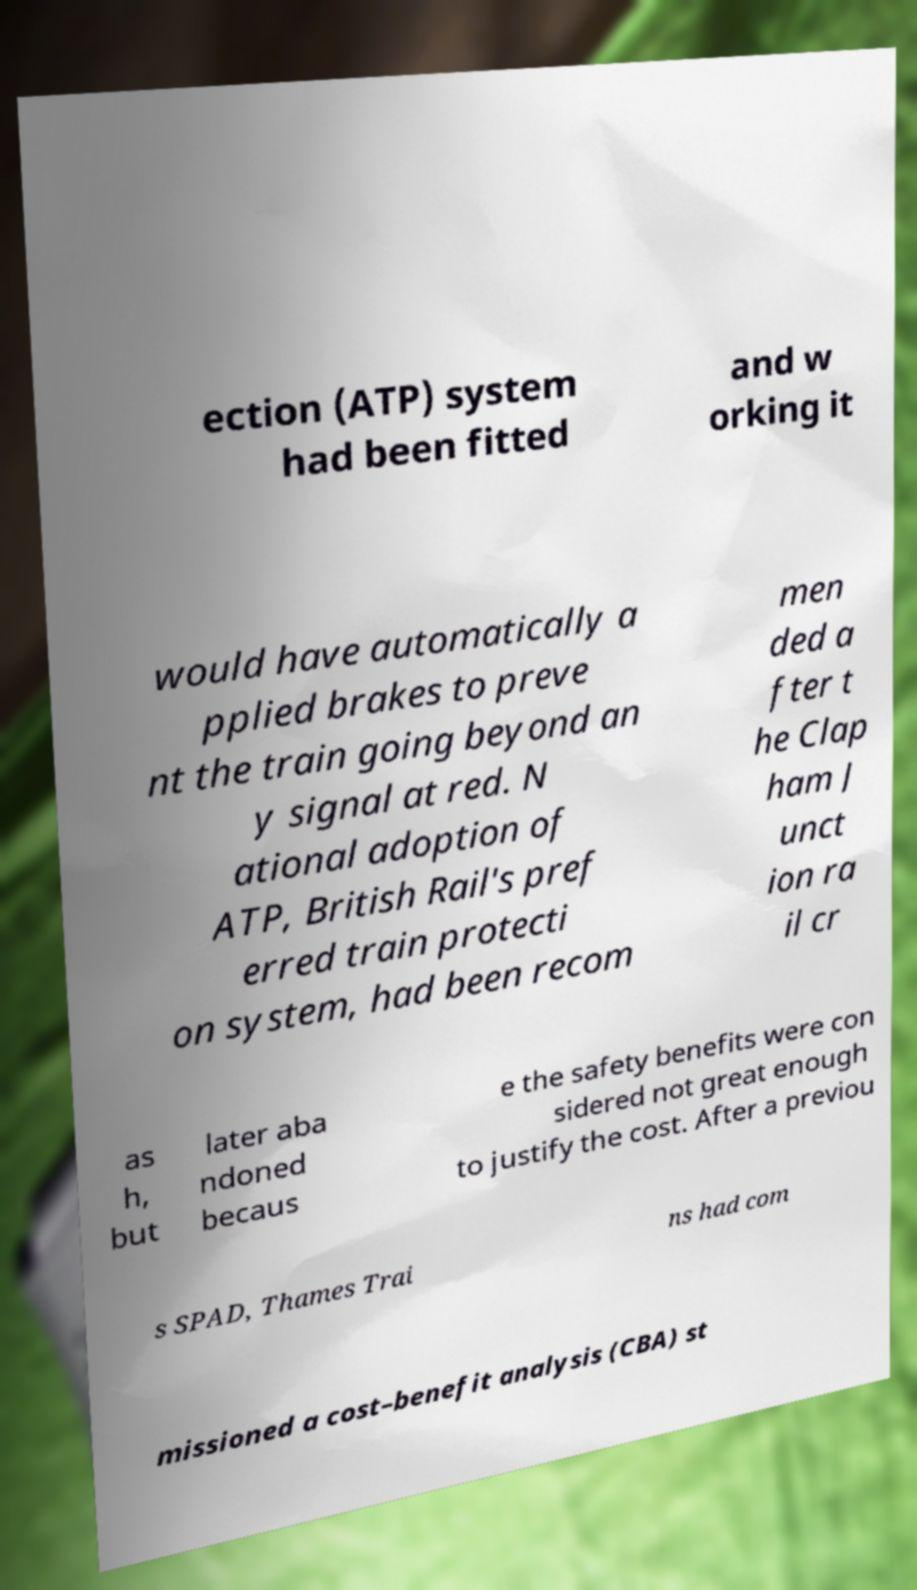Please identify and transcribe the text found in this image. ection (ATP) system had been fitted and w orking it would have automatically a pplied brakes to preve nt the train going beyond an y signal at red. N ational adoption of ATP, British Rail's pref erred train protecti on system, had been recom men ded a fter t he Clap ham J unct ion ra il cr as h, but later aba ndoned becaus e the safety benefits were con sidered not great enough to justify the cost. After a previou s SPAD, Thames Trai ns had com missioned a cost–benefit analysis (CBA) st 